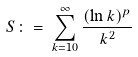Convert formula to latex. <formula><loc_0><loc_0><loc_500><loc_500>S \, \colon = \, \sum _ { k = 1 0 } ^ { \infty } \frac { ( \ln k ) ^ { p } } { k ^ { 2 } }</formula> 